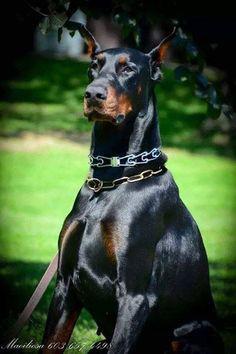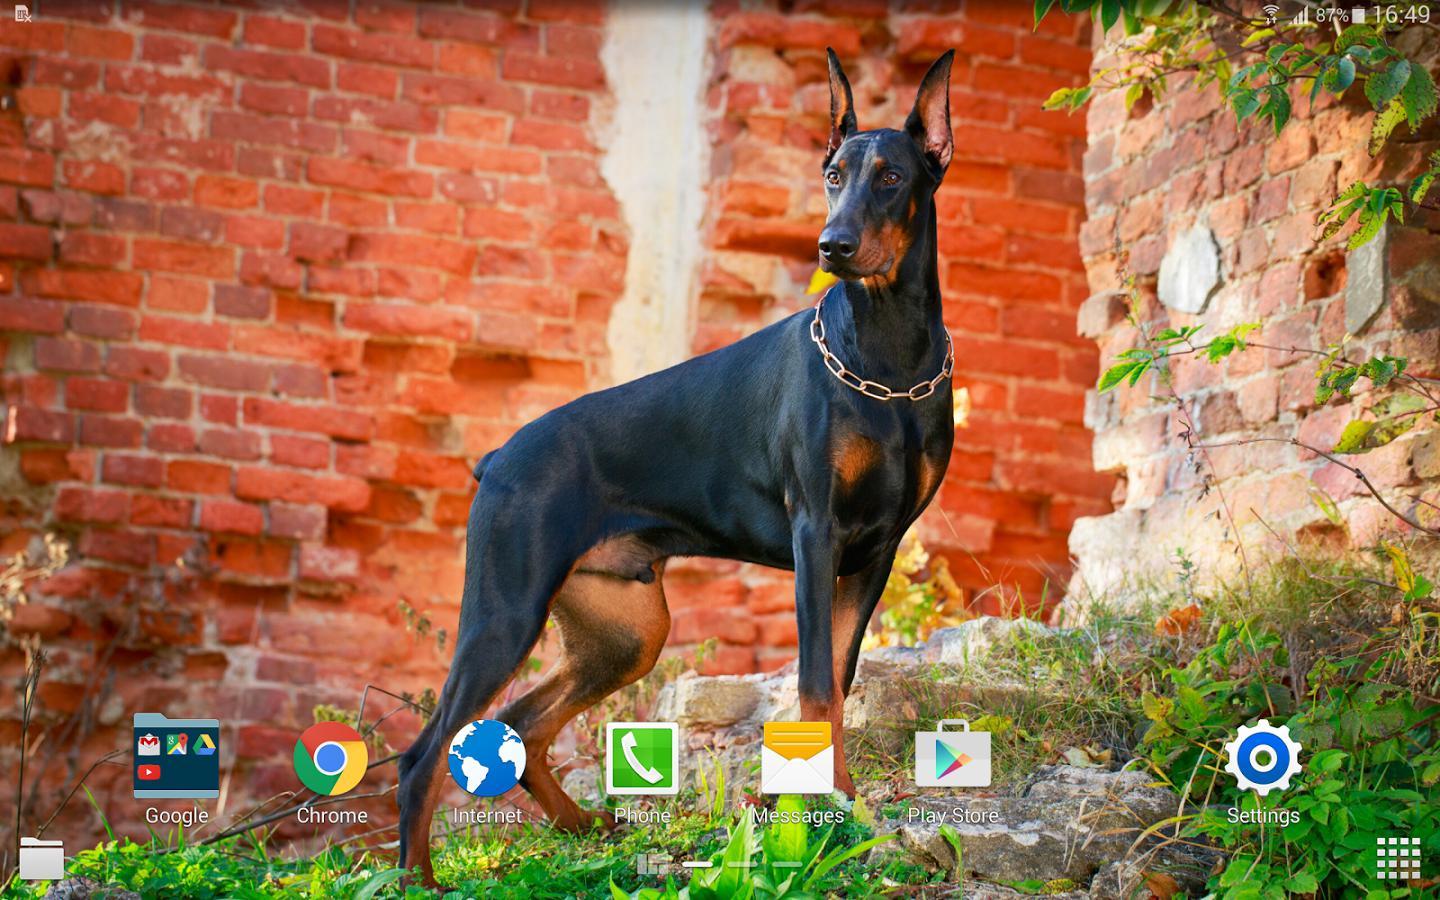The first image is the image on the left, the second image is the image on the right. Examine the images to the left and right. Is the description "A dog is outside near a building in one of the buildings." accurate? Answer yes or no. Yes. The first image is the image on the left, the second image is the image on the right. Assess this claim about the two images: "Each image contains one erect-eared doberman posed outdoors, and one image shows a standing dog with front feet elevated and body turned rightward in front of autumn colors.". Correct or not? Answer yes or no. Yes. 